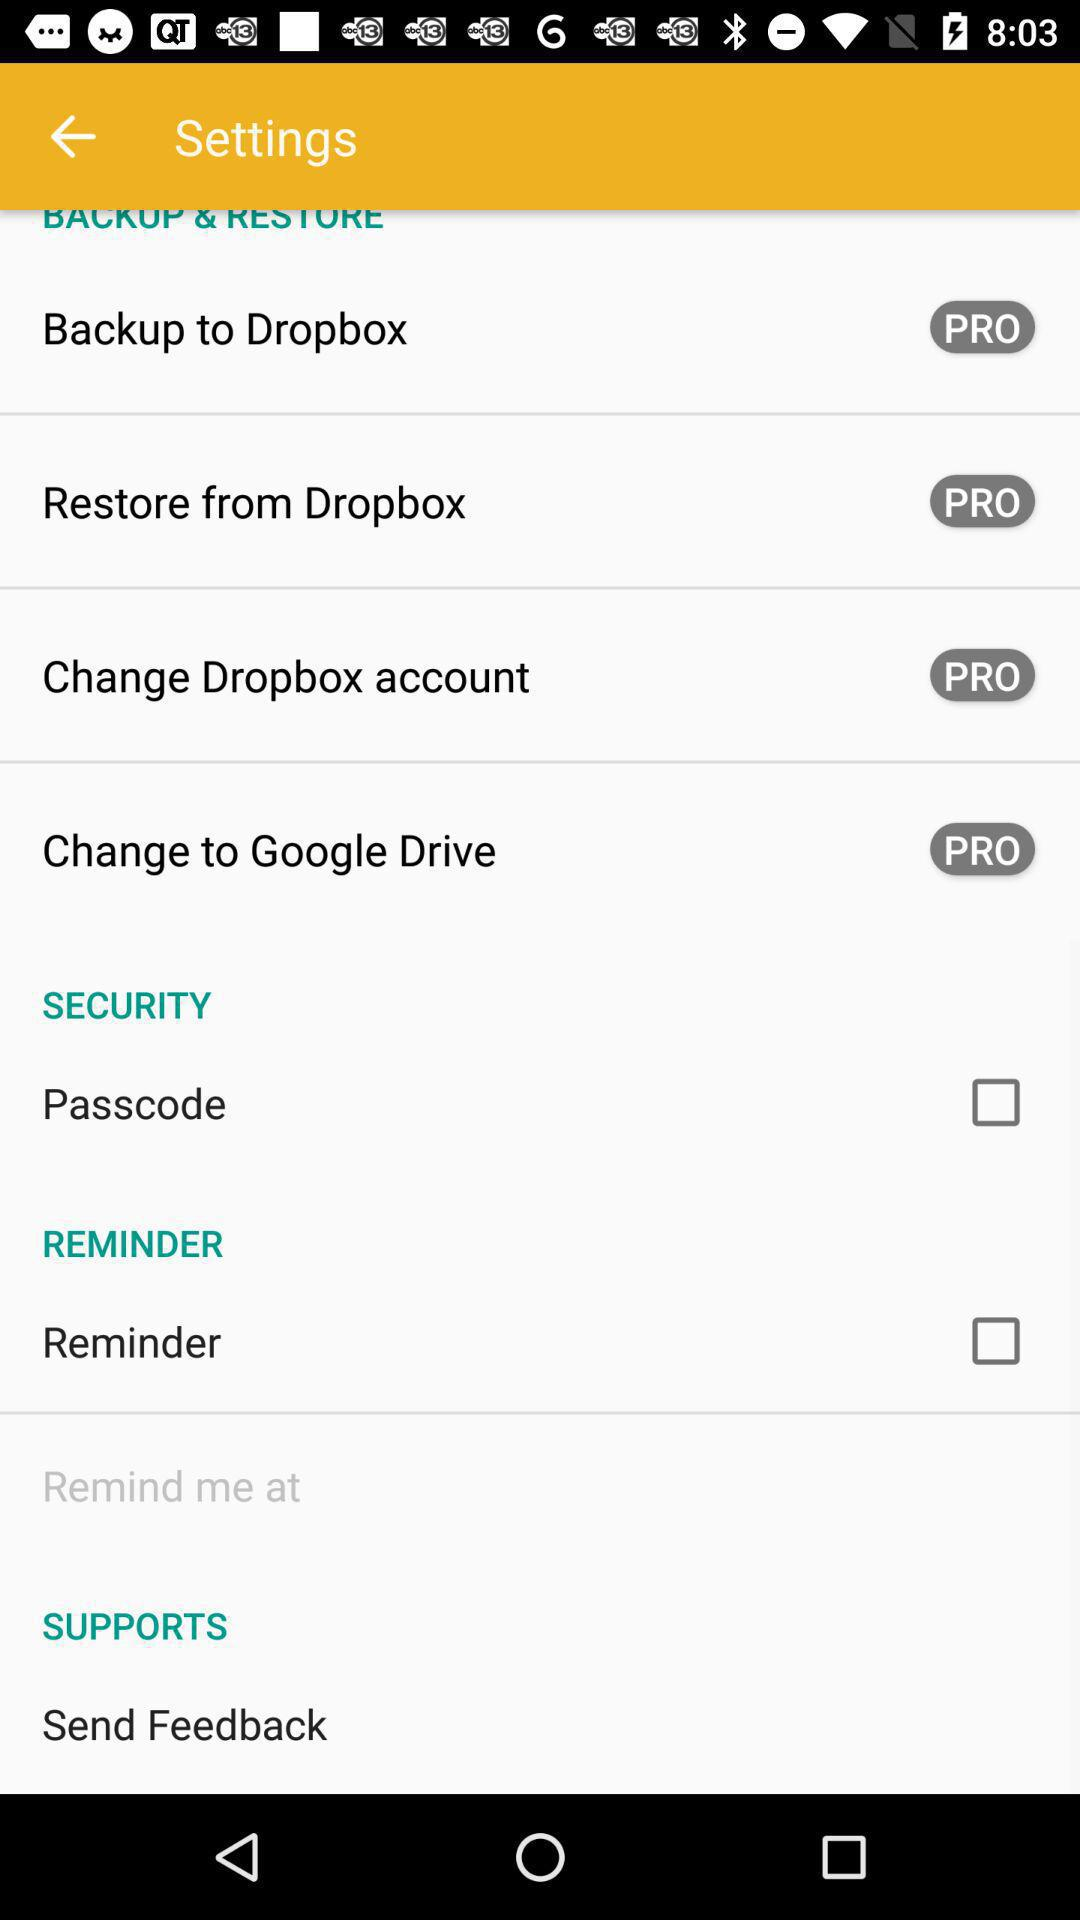What is the status of "Reminder"? The status of "Reminder" is "off". 